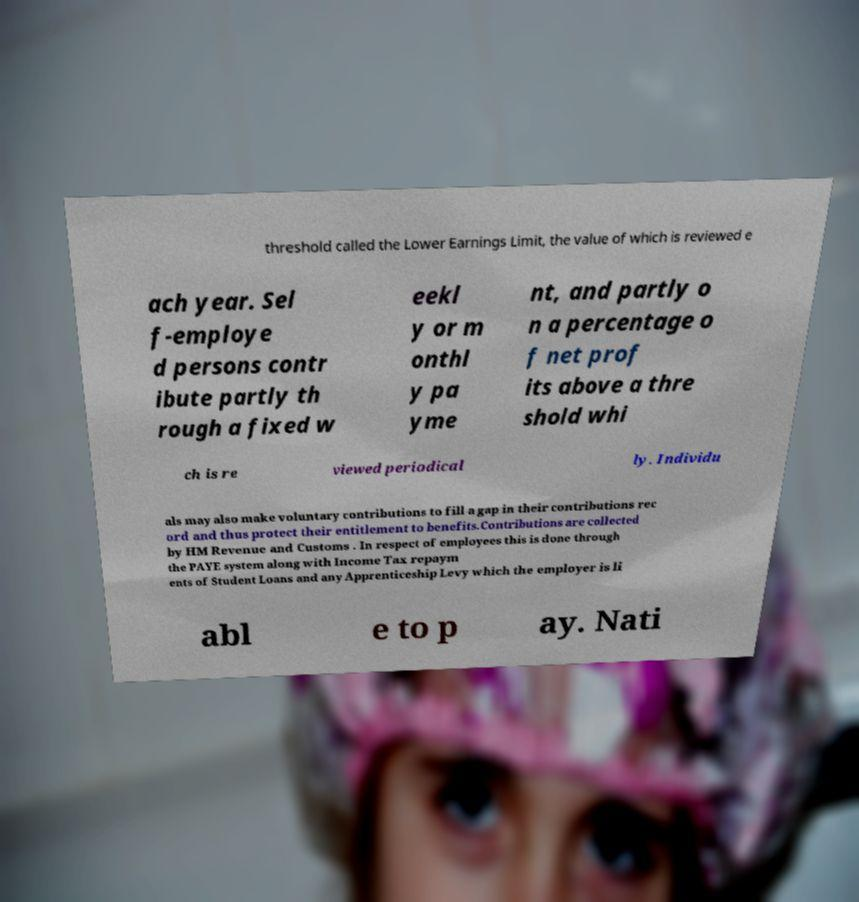Could you extract and type out the text from this image? threshold called the Lower Earnings Limit, the value of which is reviewed e ach year. Sel f-employe d persons contr ibute partly th rough a fixed w eekl y or m onthl y pa yme nt, and partly o n a percentage o f net prof its above a thre shold whi ch is re viewed periodical ly. Individu als may also make voluntary contributions to fill a gap in their contributions rec ord and thus protect their entitlement to benefits.Contributions are collected by HM Revenue and Customs . In respect of employees this is done through the PAYE system along with Income Tax repaym ents of Student Loans and any Apprenticeship Levy which the employer is li abl e to p ay. Nati 